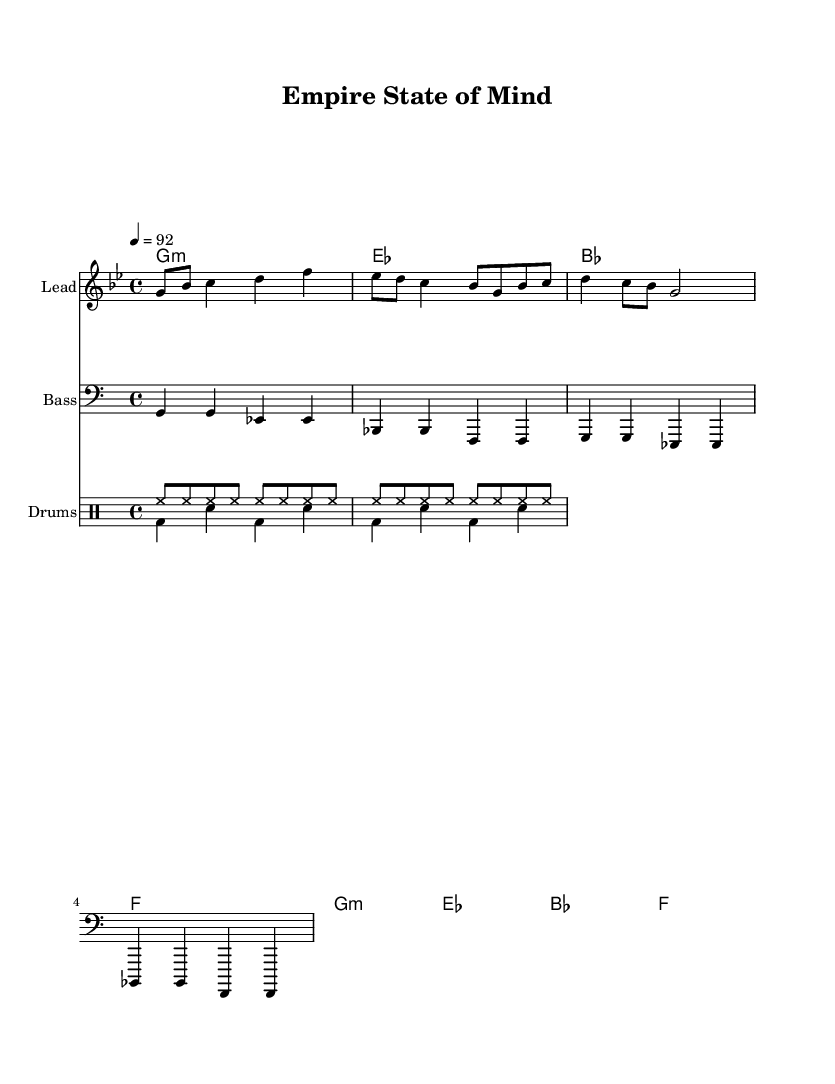What is the title of this music? The title is written at the top of the sheet music under the header section. It indicates the main name of the piece.
Answer: Empire State of Mind What is the key signature of this music? The key signature is indicated at the beginning of the staff. Here, it is G minor, which contains two flats (B flat and E flat).
Answer: G minor What is the time signature of this music? The time signature is found next to the key signature. It indicates how many beats are in each measure. In this sheet music, it is 4/4.
Answer: 4/4 What is the tempo marking for this piece? The tempo is found in the global section of the code, where it states "4 = 92", meaning there should be 92 beats per minute.
Answer: 92 How many measures are in the melody? To find this, we count the number of distinct groupings in the melody line. There are four measures present in the provided melody.
Answer: 4 What is the primary style of this music piece? The overall feel of the music, combined with the specific genre indicated in your prompt, reflects the essence of upbeat hip-hop.
Answer: Hip-hop Which instrument is intended to play the bass line? The bass line is indicated by the clef notation at the start of that staff, specifying that it is to be played by a bass instrument.
Answer: Bass 